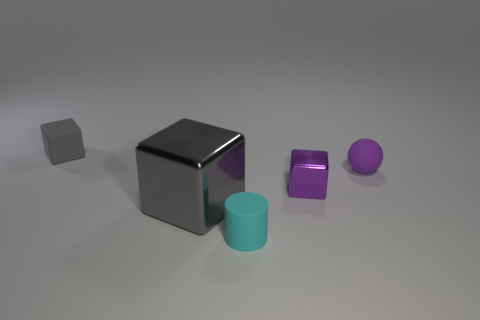What is the material of the other cube that is the same color as the rubber cube?
Give a very brief answer. Metal. How many objects are cubes that are right of the tiny matte cylinder or big purple metallic objects?
Ensure brevity in your answer.  1. How many things are small yellow things or blocks that are in front of the gray rubber thing?
Your answer should be very brief. 2. How many small blocks are behind the tiny thing that is right of the metal thing that is behind the gray shiny cube?
Make the answer very short. 1. What material is the purple sphere that is the same size as the rubber cylinder?
Ensure brevity in your answer.  Rubber. Is there another cyan matte object of the same size as the cyan rubber object?
Your answer should be very brief. No. What is the color of the tiny shiny thing?
Your answer should be very brief. Purple. What color is the shiny thing that is behind the gray thing that is in front of the tiny gray cube?
Your answer should be compact. Purple. The matte object that is in front of the tiny purple matte ball to the right of the tiny object on the left side of the matte cylinder is what shape?
Offer a terse response. Cylinder. What number of other blocks are the same material as the tiny purple cube?
Offer a very short reply. 1. 